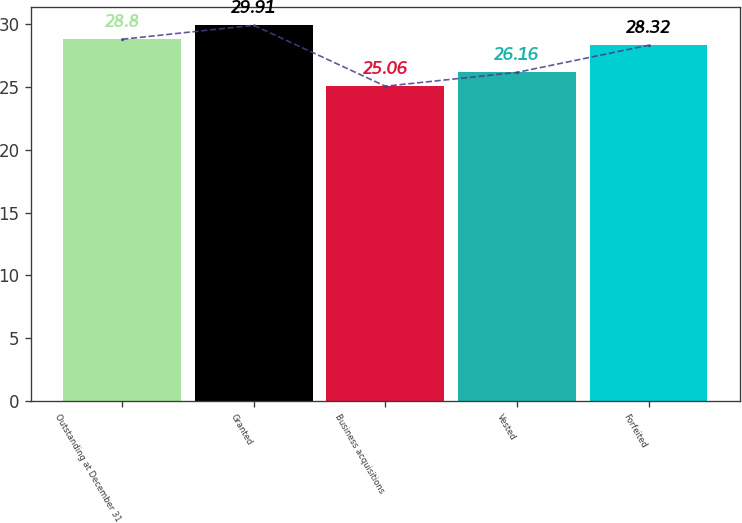Convert chart to OTSL. <chart><loc_0><loc_0><loc_500><loc_500><bar_chart><fcel>Outstanding at December 31<fcel>Granted<fcel>Business acquisitions<fcel>Vested<fcel>Forfeited<nl><fcel>28.8<fcel>29.91<fcel>25.06<fcel>26.16<fcel>28.32<nl></chart> 